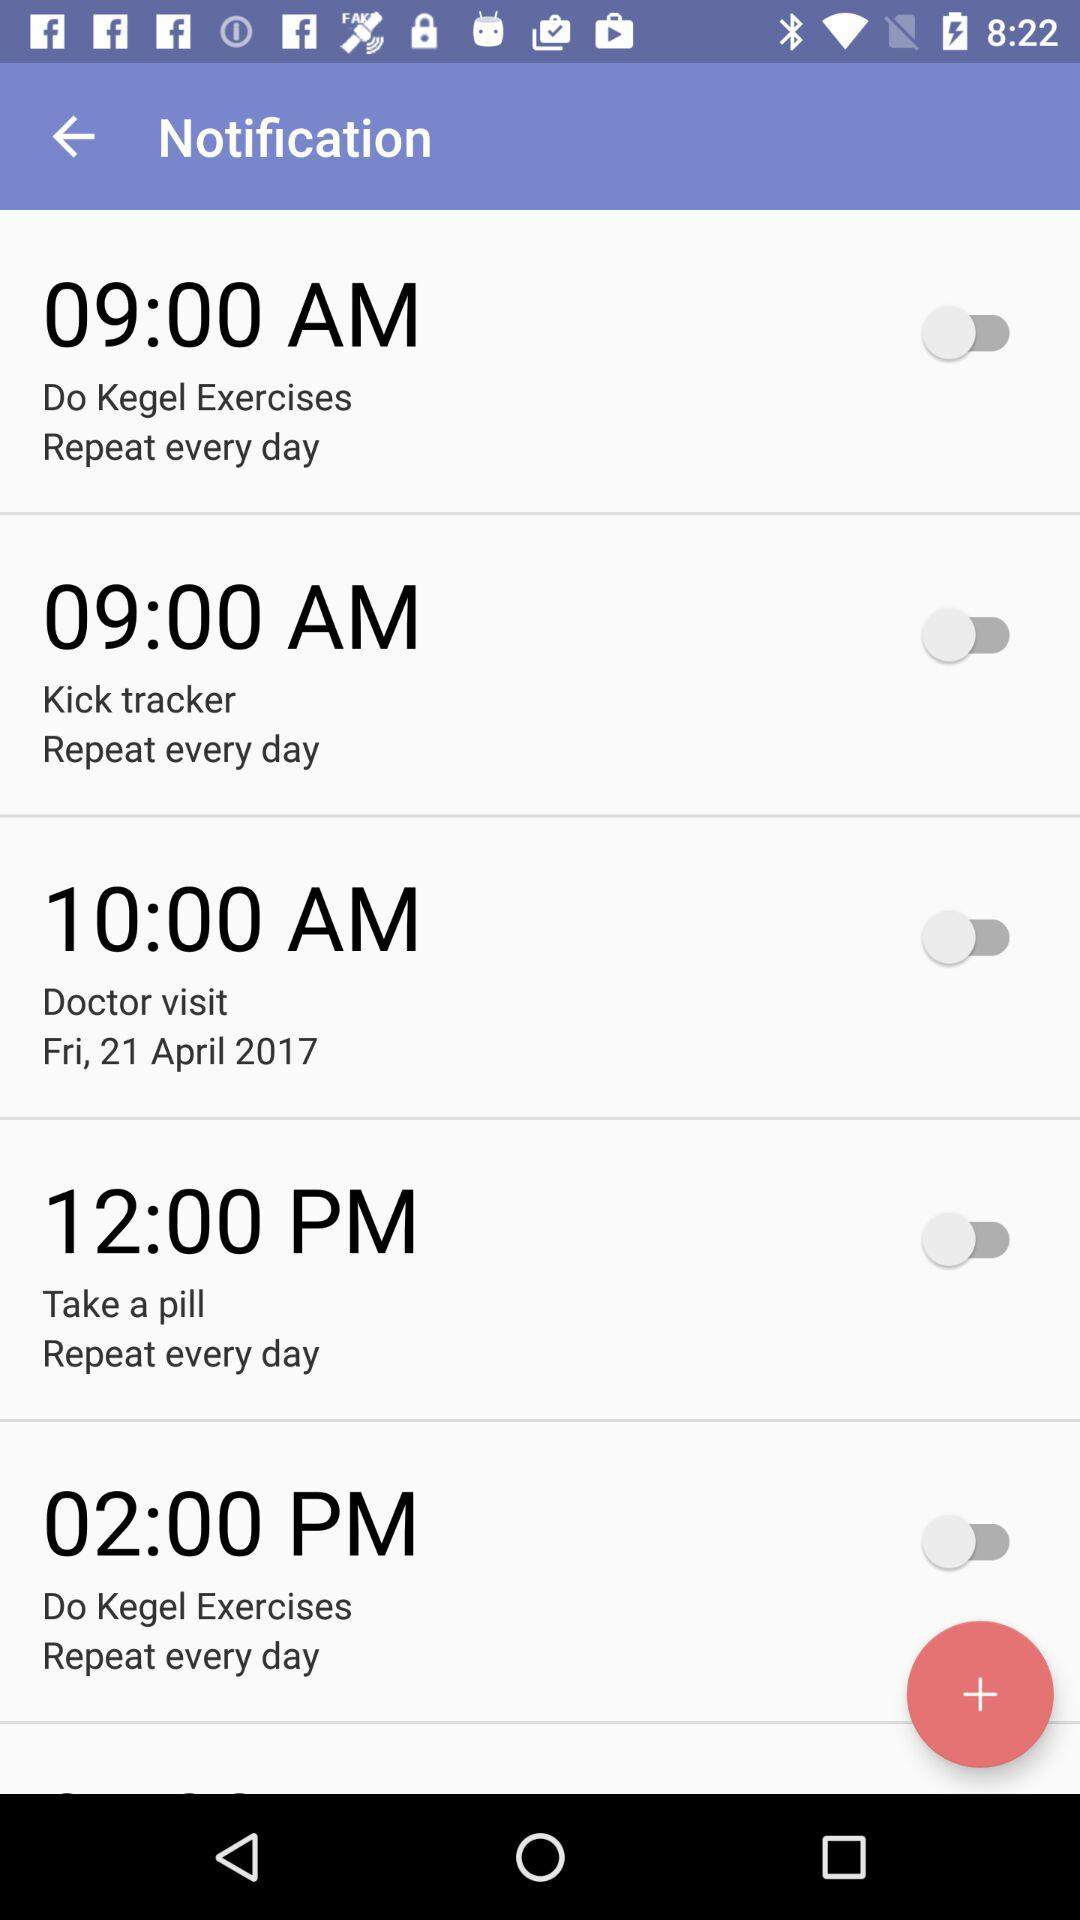What is the date and time for the doctor visit? The date and time for the doctor visit is Friday, April 21, 2017 at 10:00 AM. 